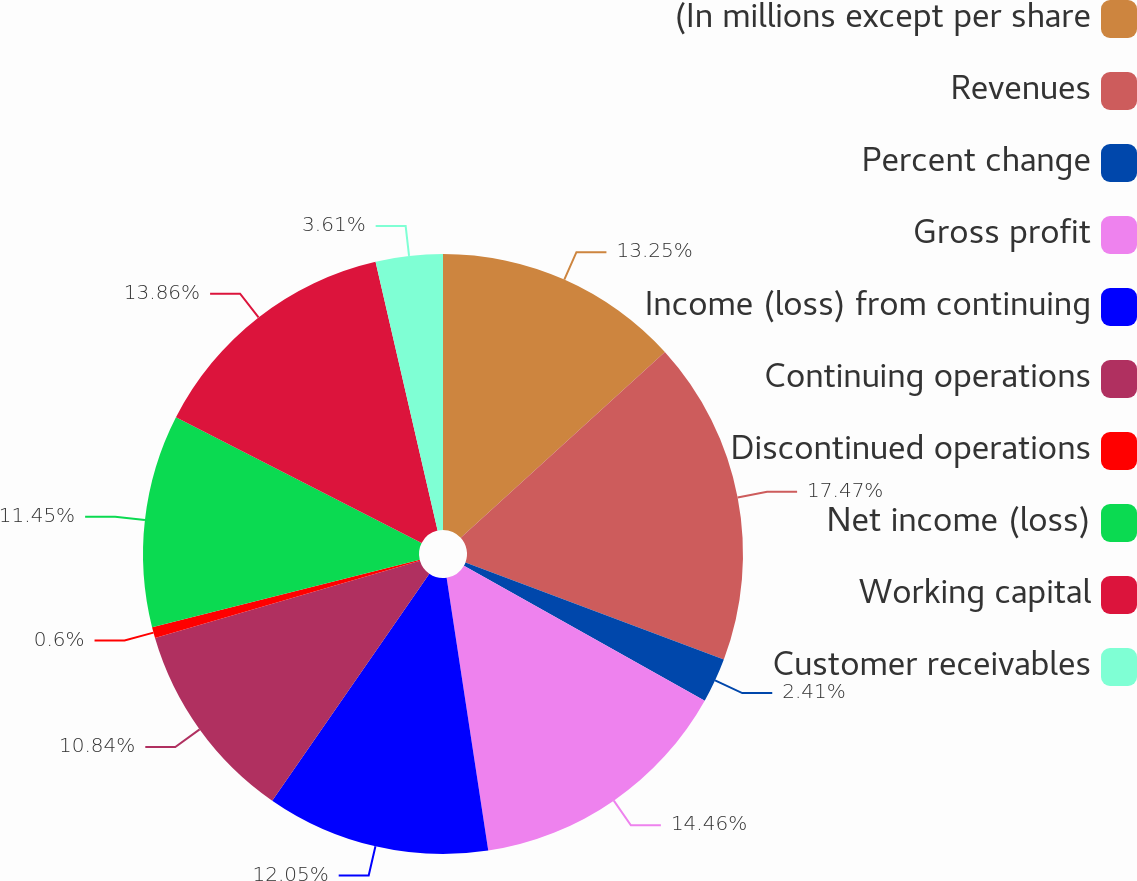<chart> <loc_0><loc_0><loc_500><loc_500><pie_chart><fcel>(In millions except per share<fcel>Revenues<fcel>Percent change<fcel>Gross profit<fcel>Income (loss) from continuing<fcel>Continuing operations<fcel>Discontinued operations<fcel>Net income (loss)<fcel>Working capital<fcel>Customer receivables<nl><fcel>13.25%<fcel>17.47%<fcel>2.41%<fcel>14.46%<fcel>12.05%<fcel>10.84%<fcel>0.6%<fcel>11.45%<fcel>13.86%<fcel>3.61%<nl></chart> 